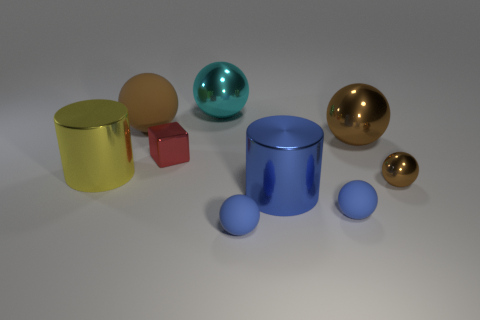How many brown spheres must be subtracted to get 1 brown spheres? 2 Subtract all brown shiny spheres. How many spheres are left? 4 Subtract all gray blocks. How many blue balls are left? 2 Subtract all brown balls. How many balls are left? 3 Add 1 brown rubber spheres. How many objects exist? 10 Subtract 2 balls. How many balls are left? 4 Subtract all blocks. How many objects are left? 8 Subtract all yellow cylinders. Subtract all blue rubber spheres. How many objects are left? 6 Add 8 red objects. How many red objects are left? 9 Add 7 red matte objects. How many red matte objects exist? 7 